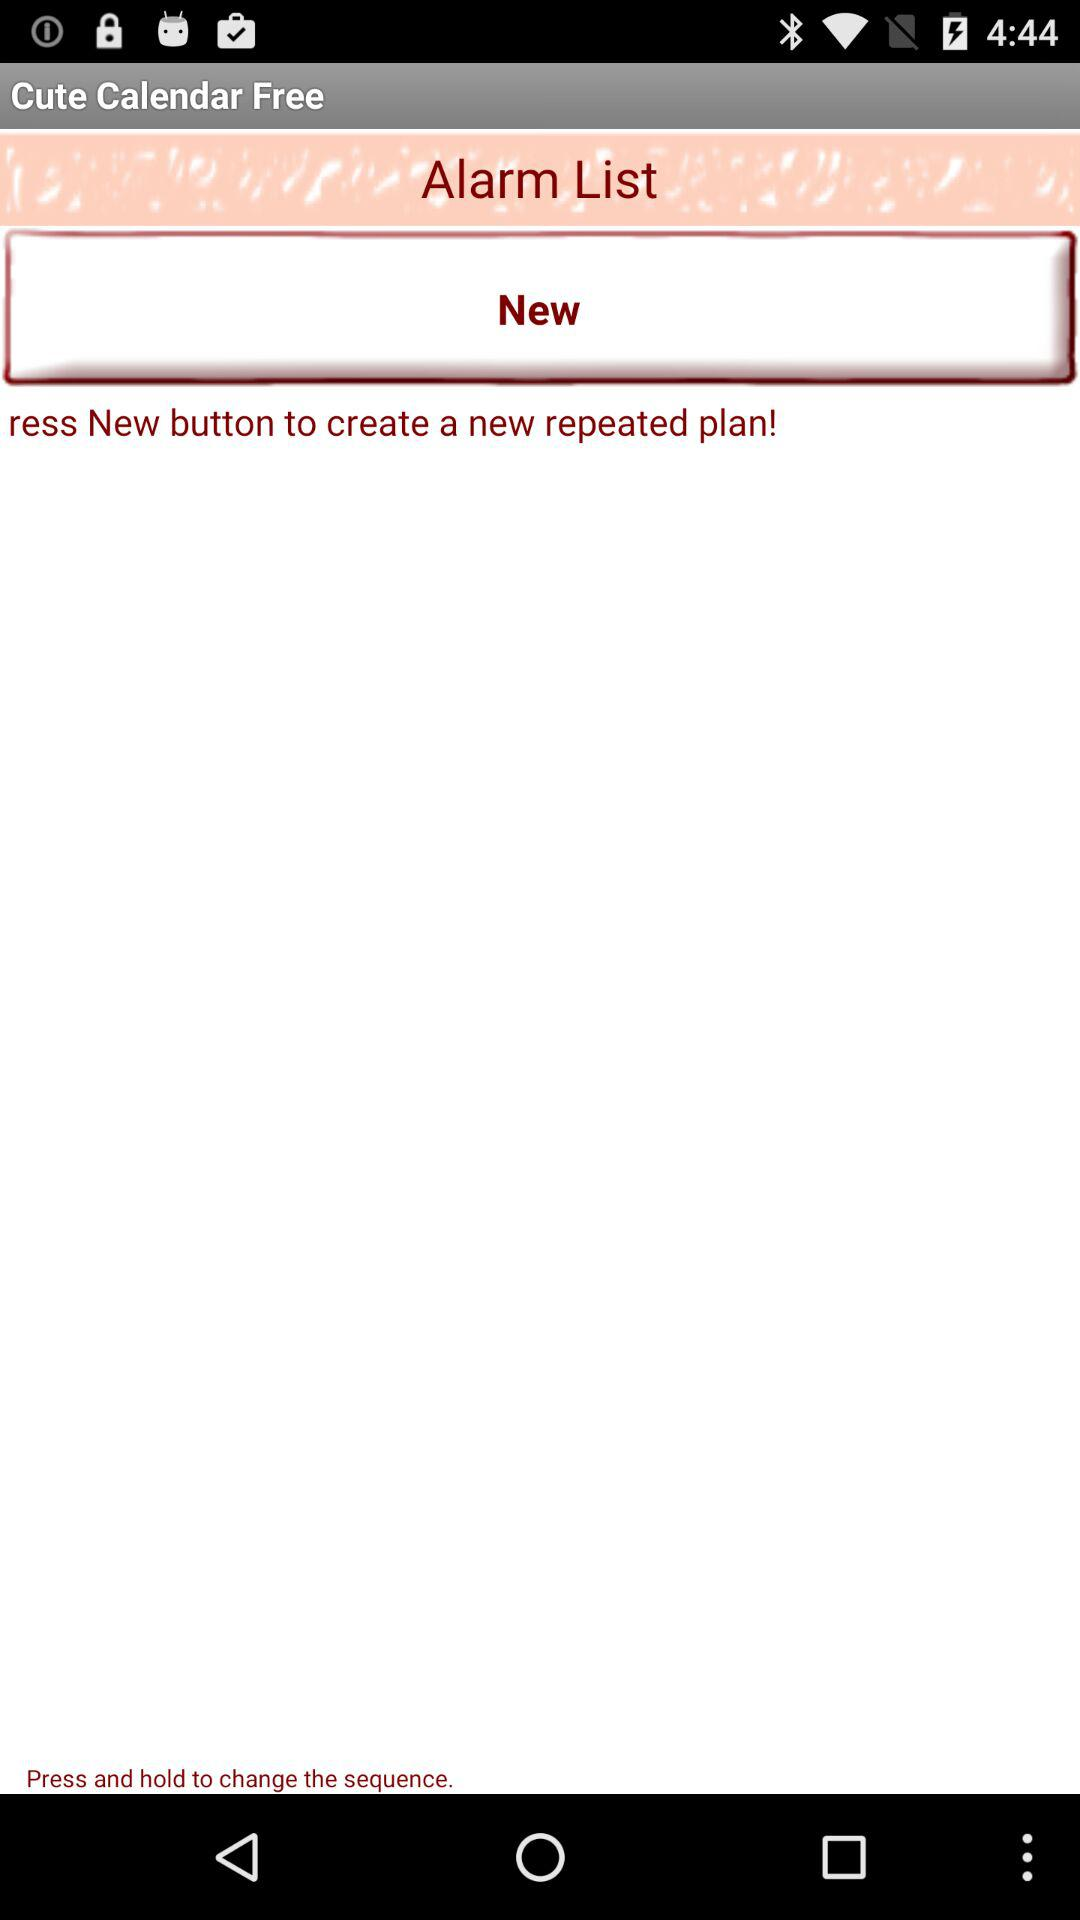What is the name of the application? The application displayed in the image is called 'Cute Calendar Free'. It appears to be a scheduling tool that offers features for setting alarms, potentially with options for repeated reminders as indicated by the 'New' button which suggests the creation of a new repeated plan. 